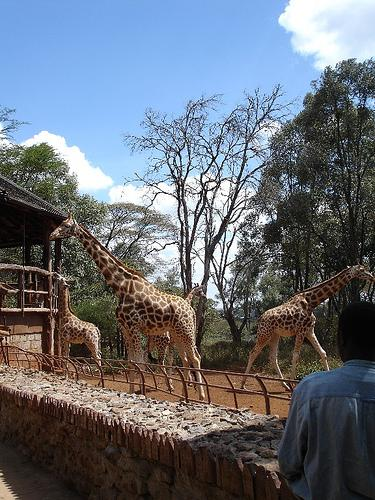What prevents the Giraffes from escaping the fence? Please explain your reasoning. it's width. The fence is long but prevents the giraffe. 